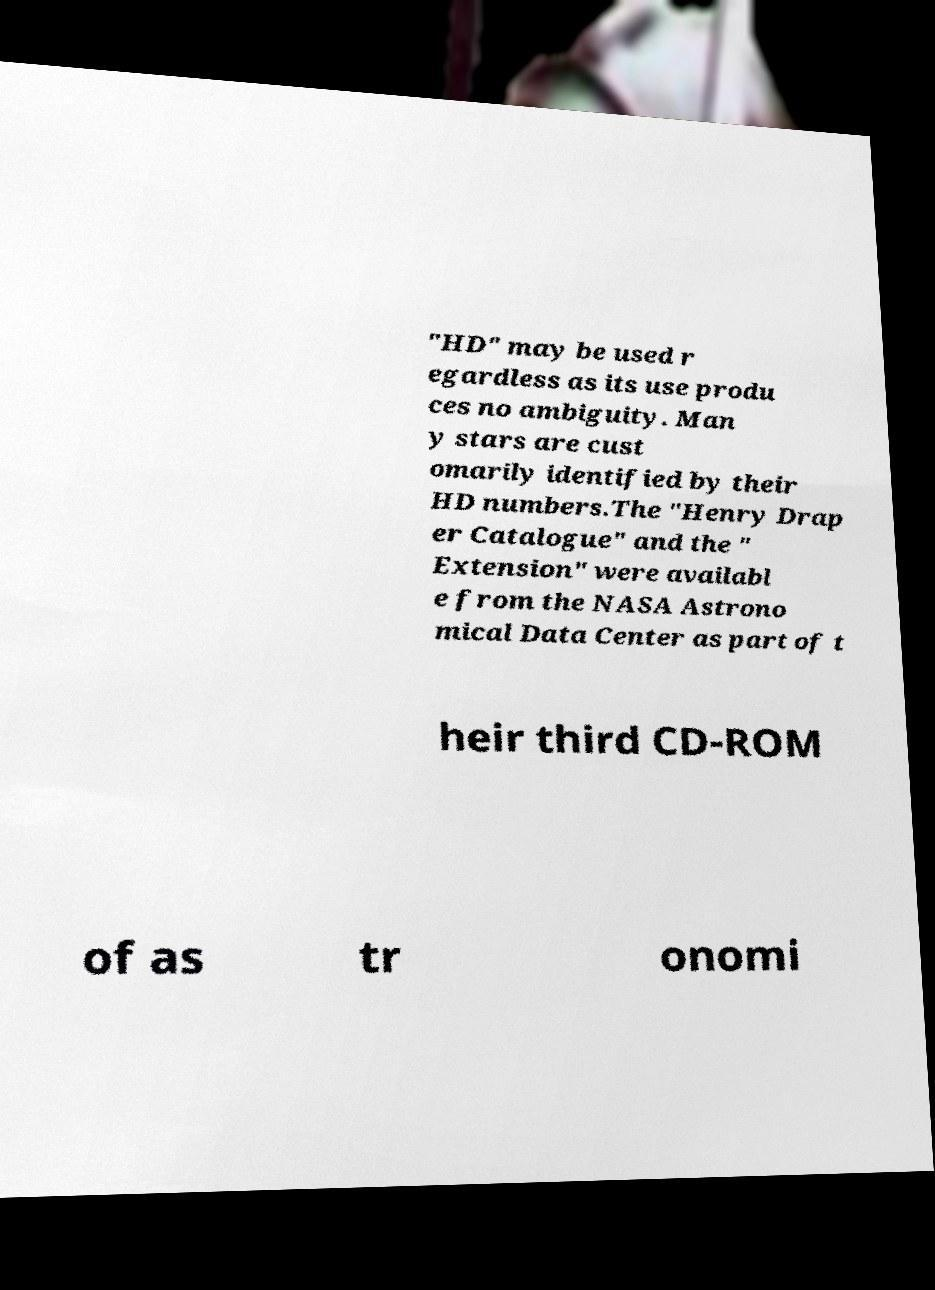What messages or text are displayed in this image? I need them in a readable, typed format. "HD" may be used r egardless as its use produ ces no ambiguity. Man y stars are cust omarily identified by their HD numbers.The "Henry Drap er Catalogue" and the " Extension" were availabl e from the NASA Astrono mical Data Center as part of t heir third CD-ROM of as tr onomi 